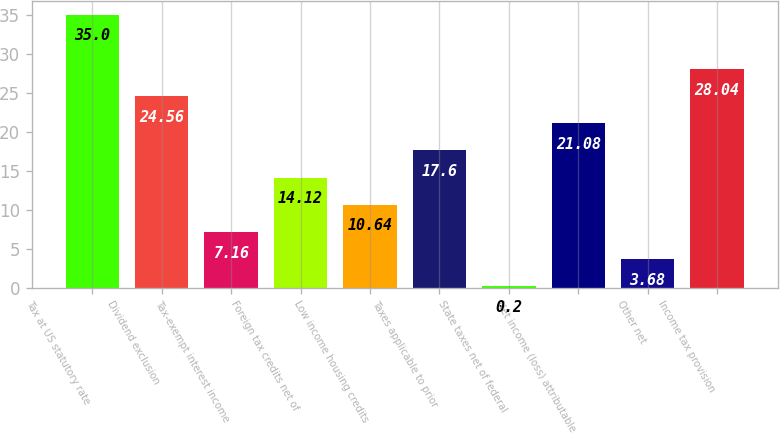<chart> <loc_0><loc_0><loc_500><loc_500><bar_chart><fcel>Tax at US statutory rate<fcel>Dividend exclusion<fcel>Tax-exempt interest income<fcel>Foreign tax credits net of<fcel>Low income housing credits<fcel>Taxes applicable to prior<fcel>State taxes net of federal<fcel>Net income (loss) attributable<fcel>Other net<fcel>Income tax provision<nl><fcel>35<fcel>24.56<fcel>7.16<fcel>14.12<fcel>10.64<fcel>17.6<fcel>0.2<fcel>21.08<fcel>3.68<fcel>28.04<nl></chart> 